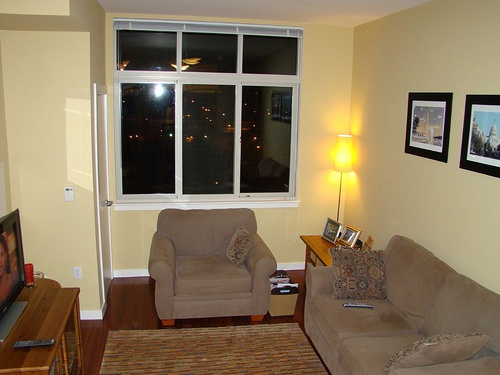Describe the objects in this image and their specific colors. I can see couch in tan, gray, and maroon tones, chair in tan, gray, brown, and maroon tones, tv in tan, black, maroon, and brown tones, remote in tan, black, gray, maroon, and purple tones, and remote in tan, gray, and black tones in this image. 